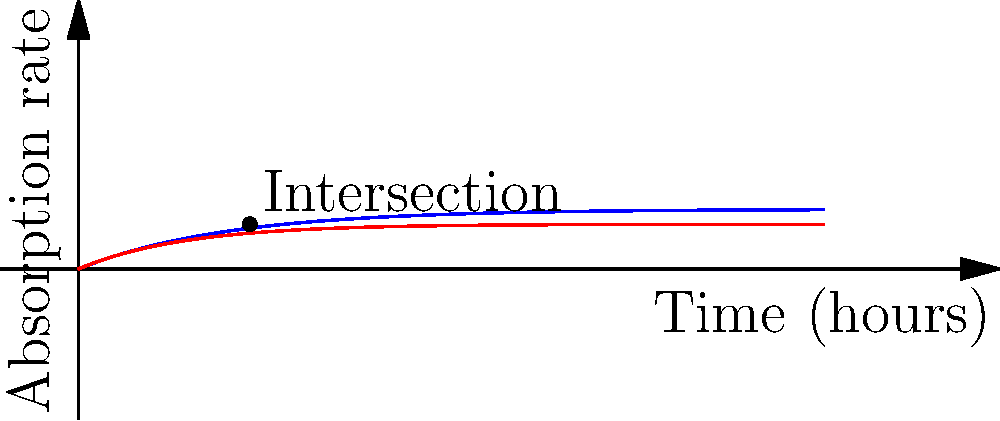Two medications, A and B, have different absorption rates in the body. Medication A's absorption rate is given by the function $f(t) = 0.8(1-e^{-0.5t})$, while Medication B's absorption rate is given by $g(t) = 0.6(1-e^{-0.7t})$, where $t$ is time in hours. At what time do these medications have the same absorption rate? Round your answer to the nearest tenth of an hour. To find the intersection point, we need to solve the equation:

$f(t) = g(t)$

$0.8(1-e^{-0.5t}) = 0.6(1-e^{-0.7t})$

Let's solve this step-by-step:

1) Expand the equations:
   $0.8 - 0.8e^{-0.5t} = 0.6 - 0.6e^{-0.7t}$

2) Subtract 0.6 from both sides:
   $0.2 - 0.8e^{-0.5t} = -0.6e^{-0.7t}$

3) Add $0.8e^{-0.5t}$ to both sides:
   $0.2 = 0.8e^{-0.5t} - 0.6e^{-0.7t}$

4) Divide both sides by 0.2:
   $1 = 4e^{-0.5t} - 3e^{-0.7t}$

This equation cannot be solved algebraically. We need to use numerical methods or graphing to find the solution.

Using a graphing calculator or computer software, we can find that the solution is approximately $t = 2.3$ hours.

This means that after about 2.3 hours, both medications will have the same absorption rate in the body.
Answer: 2.3 hours 